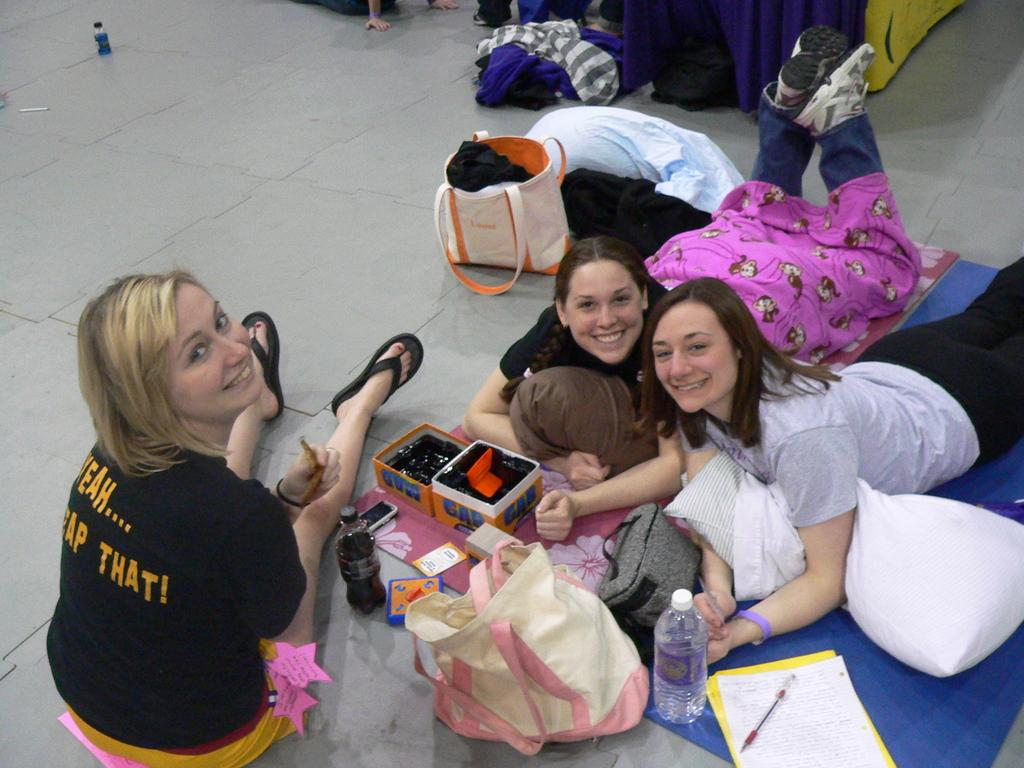<image>
Share a concise interpretation of the image provided. Black shirt with yeah gap that sign in dark yellow letters. 